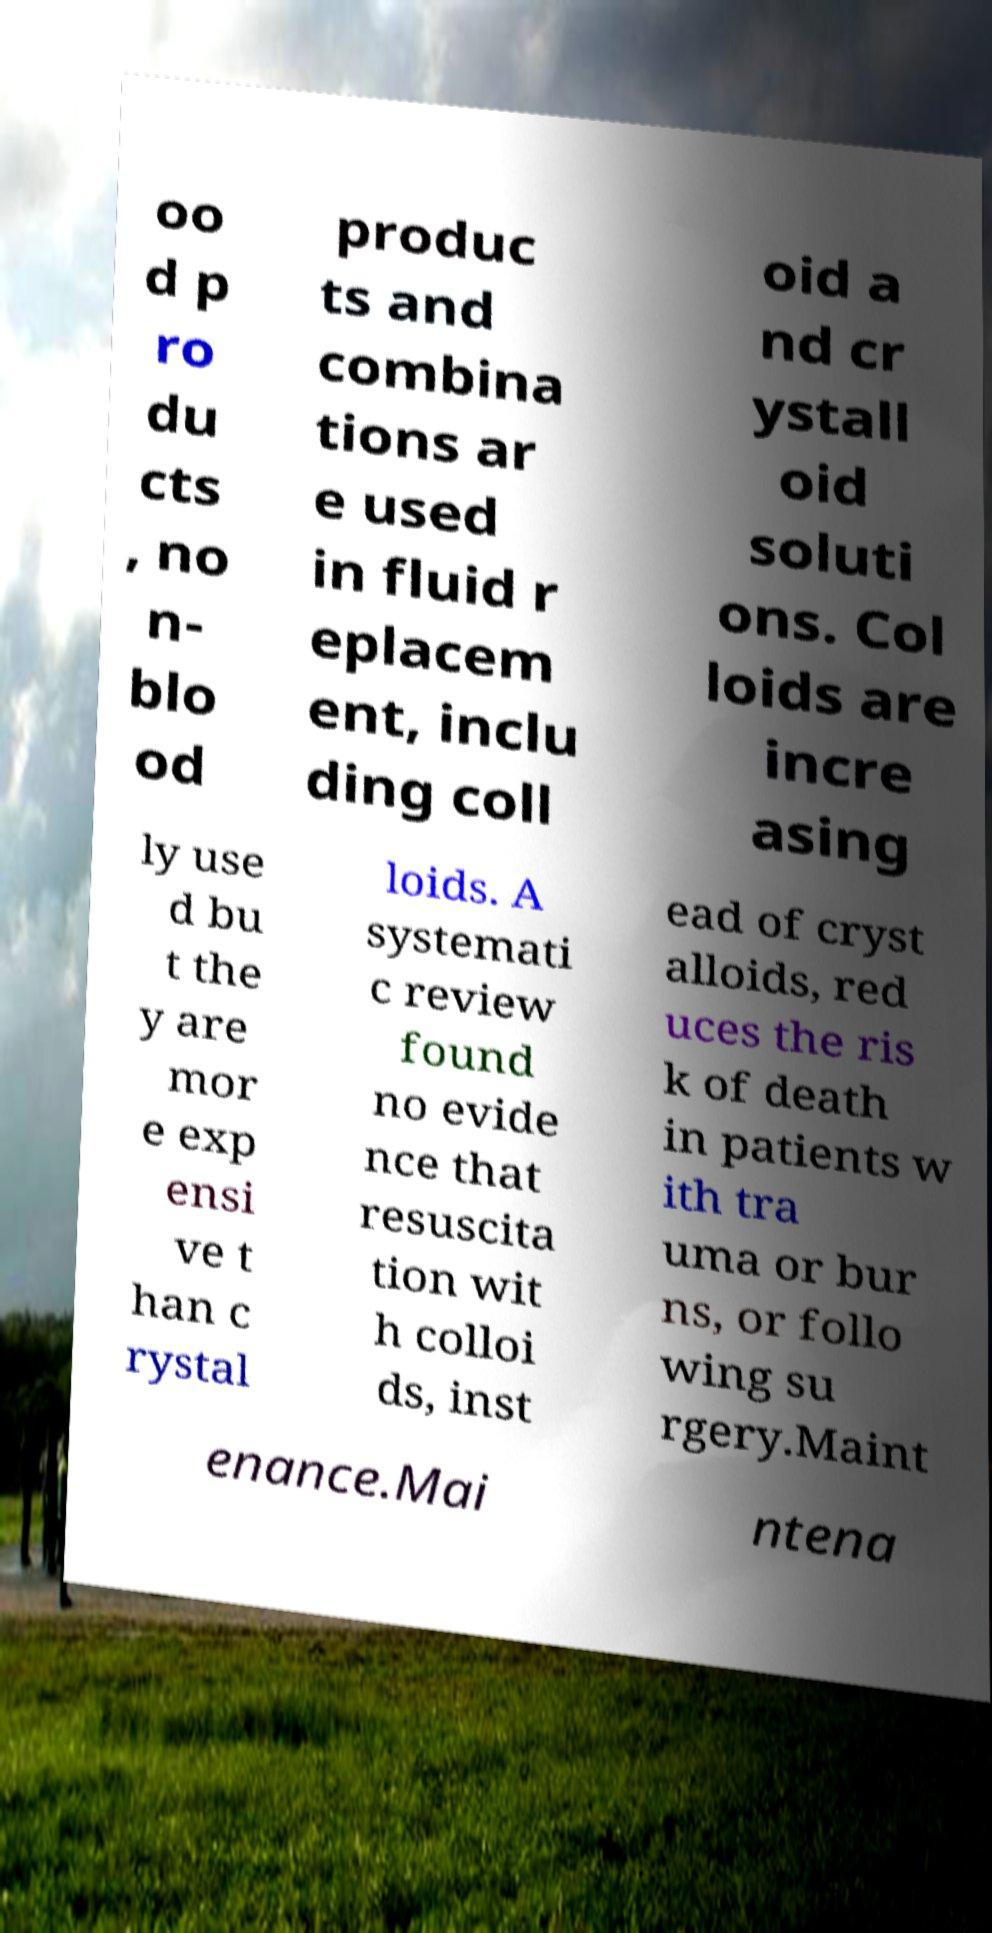I need the written content from this picture converted into text. Can you do that? oo d p ro du cts , no n- blo od produc ts and combina tions ar e used in fluid r eplacem ent, inclu ding coll oid a nd cr ystall oid soluti ons. Col loids are incre asing ly use d bu t the y are mor e exp ensi ve t han c rystal loids. A systemati c review found no evide nce that resuscita tion wit h colloi ds, inst ead of cryst alloids, red uces the ris k of death in patients w ith tra uma or bur ns, or follo wing su rgery.Maint enance.Mai ntena 